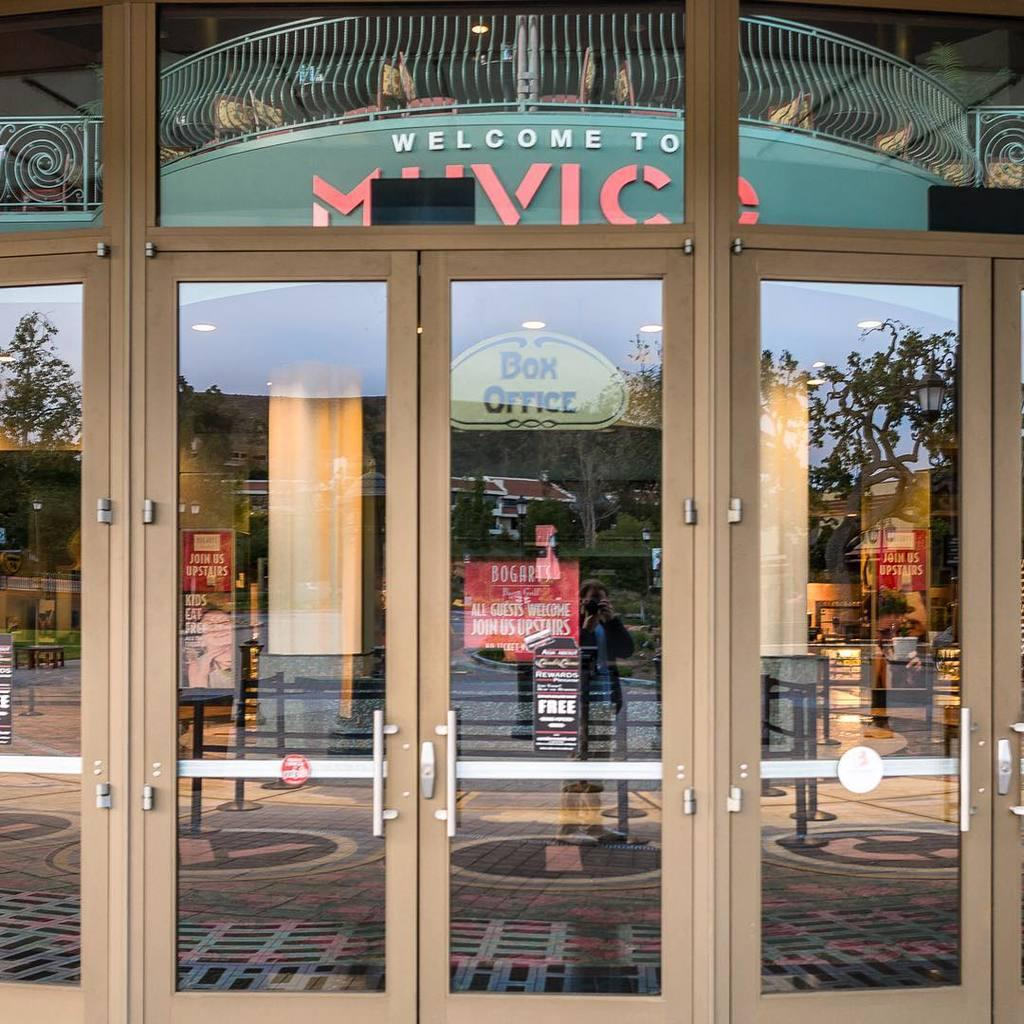What type of doors are visible in the image? There are glass doors in the image. What can be seen in the reflections on the glass doors? The glass doors have reflections of trees, people, boards, railings, and the sky. How many different types of reflections can be seen on the glass doors? There are five different types of reflections visible on the glass doors. Are there any bears visible in the image? No, there are no bears present in the image. 